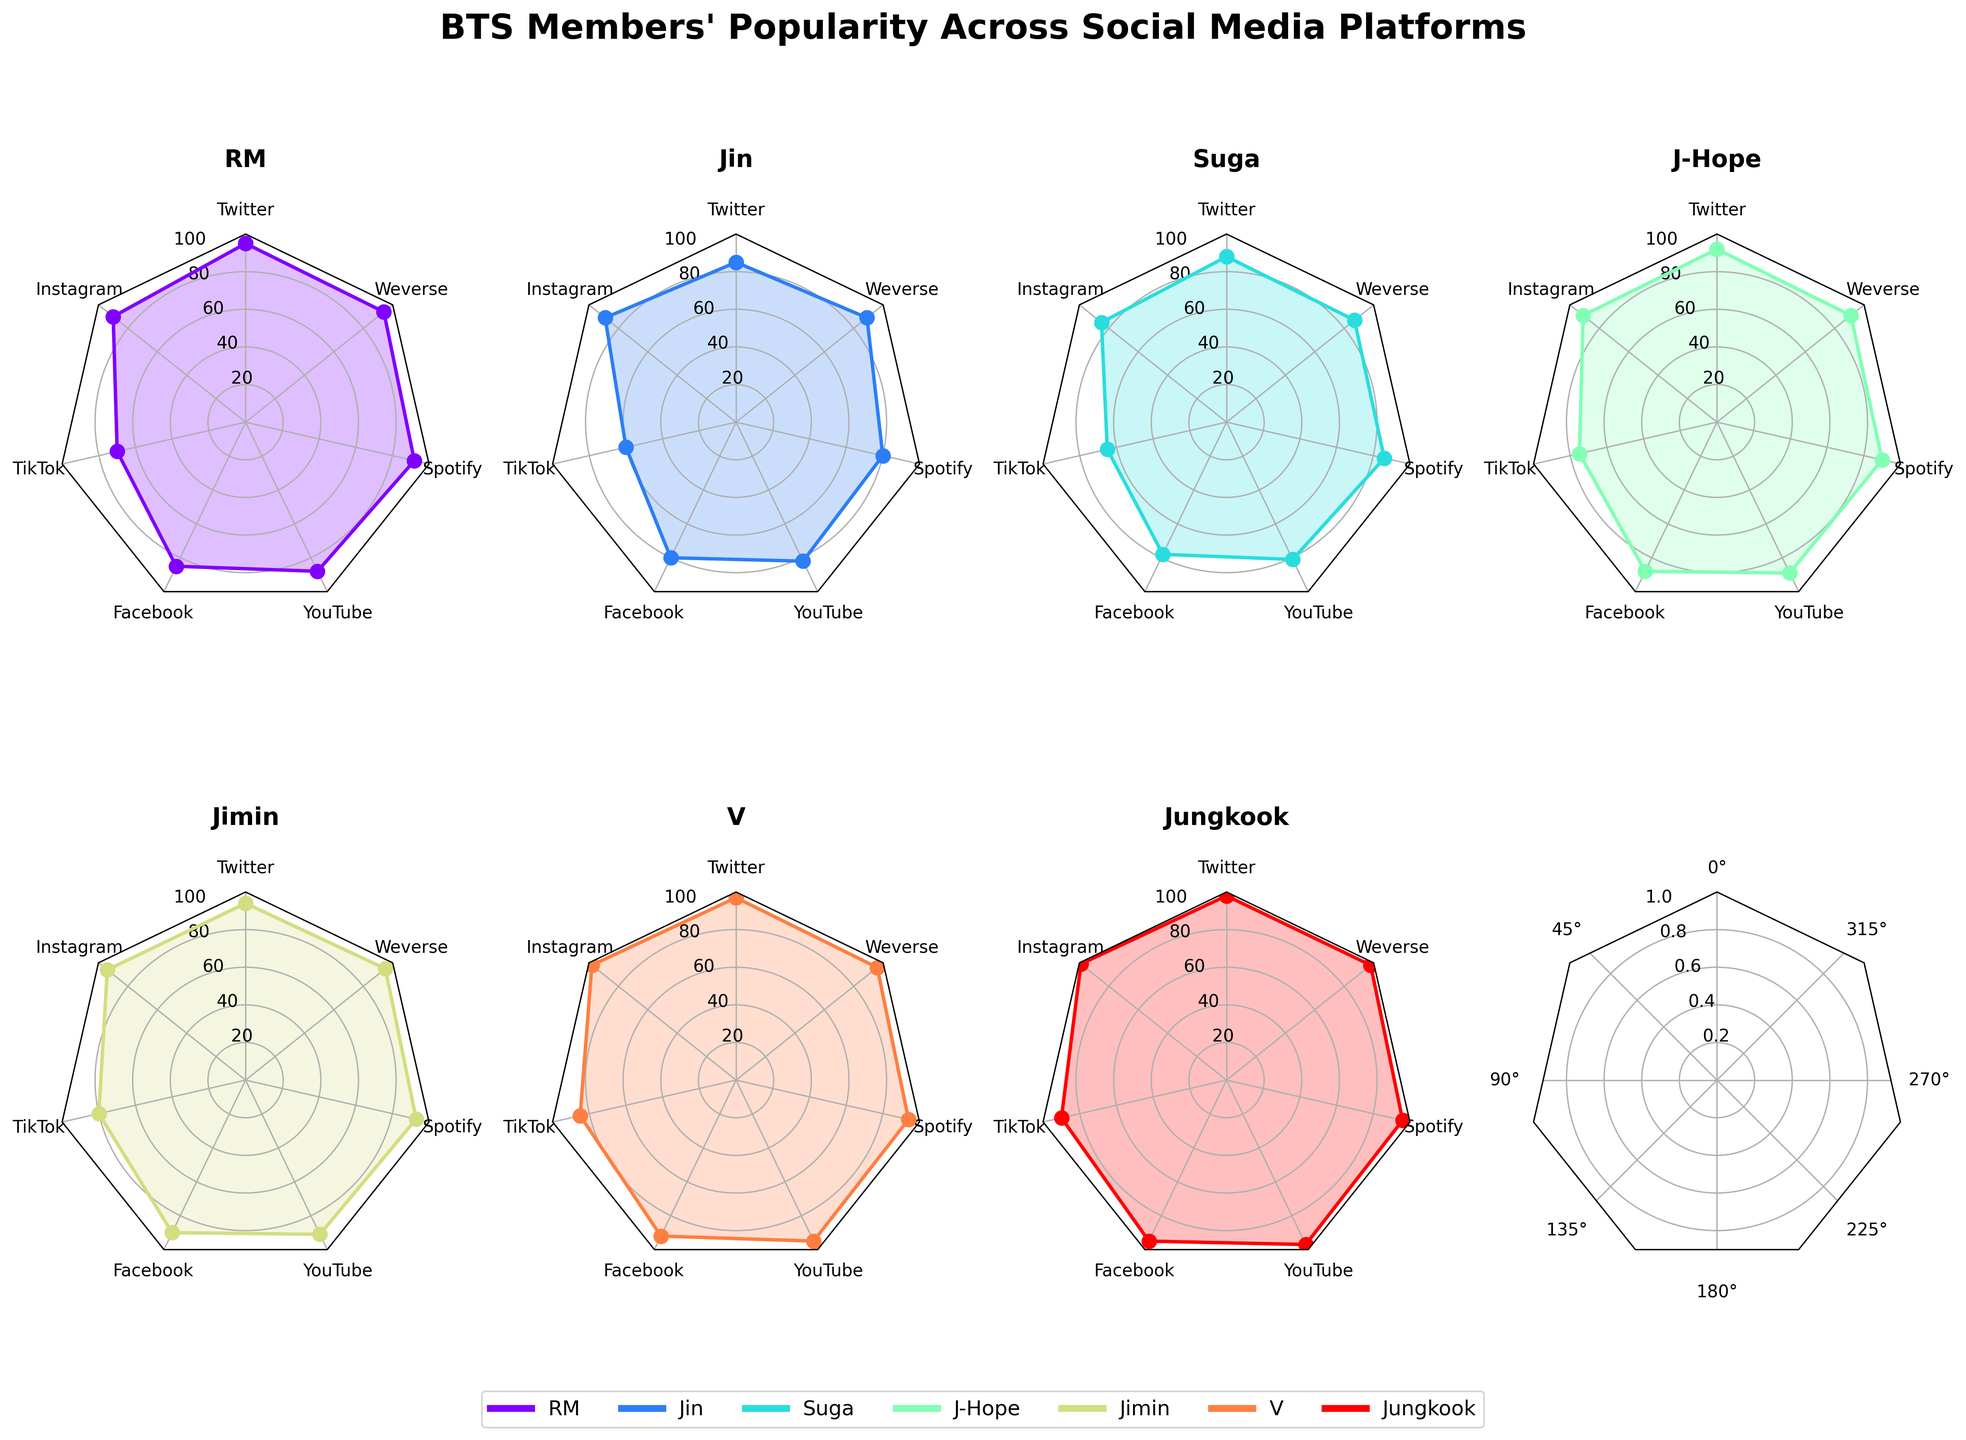What's the title of the figure? The title of the figure is displayed at the top center of the plot. You can see it as "BTS Members' Popularity Across Social Media Platforms".
Answer: BTS Members' Popularity Across Social Media Platforms What platforms are covered in the radar charts? The radial labels around each plot show the platforms included. They are Twitter, Instagram, TikTok, Facebook, YouTube, Spotify, and Weverse.
Answer: Twitter, Instagram, TikTok, Facebook, YouTube, Spotify, Weverse Which BTS member is most popular on Instagram? By looking at the values plotted for each member on the Instagram axis and finding the highest value, Jungkook stands out with the highest popularity rating.
Answer: Jungkook What is the average popularity score of RM across all platforms? By adding up RM's scores across all platforms (95 + 90 + 70 + 85 + 88 + 92 + 94) and dividing by the number of platforms (7), we get the average score. The calculation is (95 + 90 + 70 + 85 + 88 + 92 + 94) / 7 = 614 / 7 ≈ 87.71.
Answer: 87.71 On which platform does J-Hope have the highest popularity? Checking the values on each axis for J-Hope, his highest score is on Facebook (88).
Answer: Facebook Compare the popularity of Suga and Jin on TikTok. Who is more popular? Suga's score on TikTok is 65, while Jin's score is 60. Therefore, Suga is more popular on TikTok.
Answer: Suga Which BTS member has the most consistent popularity across platforms? By observing the radar charts, we look for the member whose plot is closest to a regular polygon. V has consistently high values across all platforms, indicating the most consistency.
Answer: V Between Jimin and V, who has a higher popularity score on Spotify? By comparing the plotted values on the Spotify axis for Jimin (93) and V (94), V has a slightly higher score.
Answer: V Calculate the difference in popularity between Jungkook and Jin on YouTube. Jungkook's YouTube score is 97, and Jin's YouTube score is 82. The difference is 97 - 82 = 15.
Answer: 15 How does Jungkook's popularity on Weverse compare to the group's average on that platform? Jungkook's Weverse score is 98. The group's average score on Weverse is calculated as (95 + 89 + 87 + 91 + 95 + 96 + 98) / 7 = 651 / 7 ≈ 93. Jungkook's score is above the group's average.
Answer: Above the average 